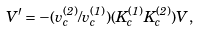<formula> <loc_0><loc_0><loc_500><loc_500>V ^ { \prime } = - ( v _ { c } ^ { ( 2 ) } / v _ { c } ^ { ( 1 ) } ) ( K _ { c } ^ { ( 1 ) } K _ { c } ^ { ( 2 ) } ) V ,</formula> 